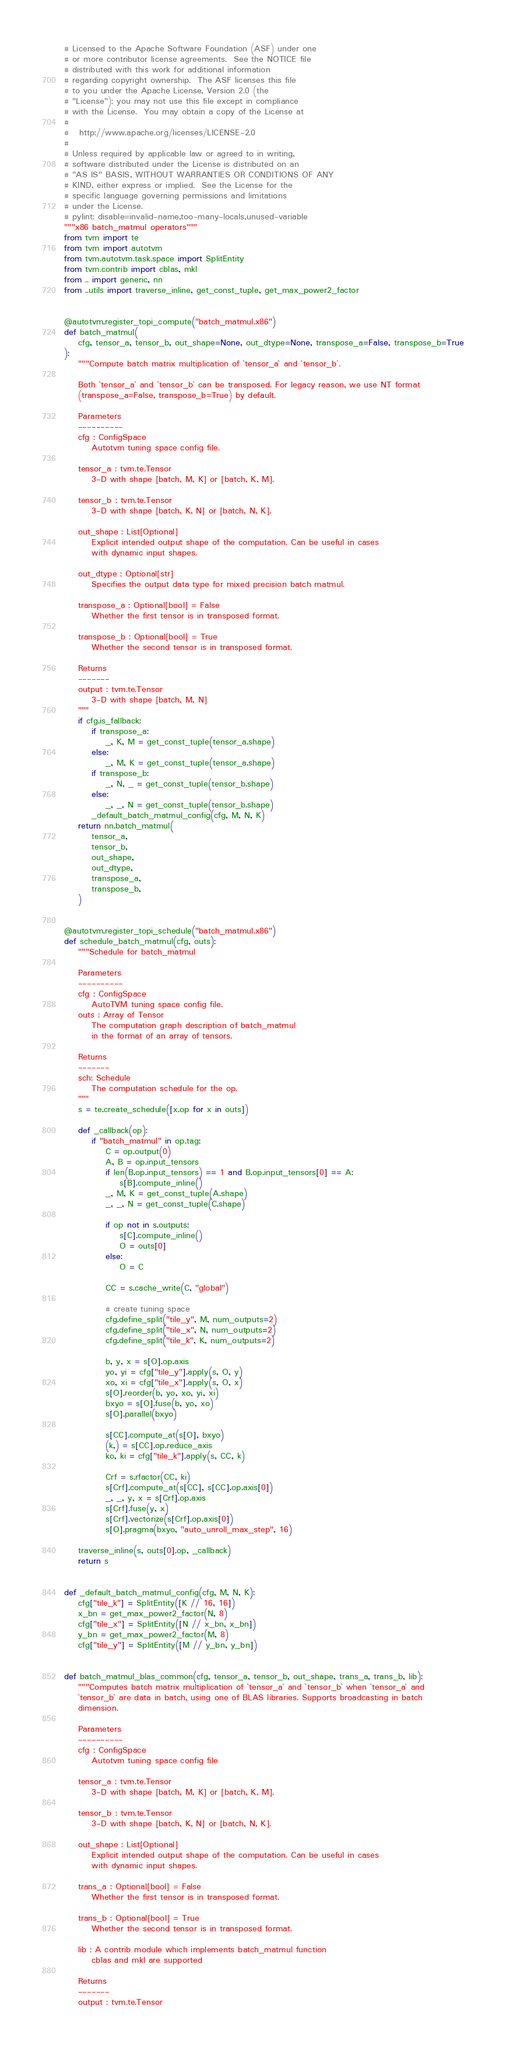Convert code to text. <code><loc_0><loc_0><loc_500><loc_500><_Python_># Licensed to the Apache Software Foundation (ASF) under one
# or more contributor license agreements.  See the NOTICE file
# distributed with this work for additional information
# regarding copyright ownership.  The ASF licenses this file
# to you under the Apache License, Version 2.0 (the
# "License"); you may not use this file except in compliance
# with the License.  You may obtain a copy of the License at
#
#   http://www.apache.org/licenses/LICENSE-2.0
#
# Unless required by applicable law or agreed to in writing,
# software distributed under the License is distributed on an
# "AS IS" BASIS, WITHOUT WARRANTIES OR CONDITIONS OF ANY
# KIND, either express or implied.  See the License for the
# specific language governing permissions and limitations
# under the License.
# pylint: disable=invalid-name,too-many-locals,unused-variable
"""x86 batch_matmul operators"""
from tvm import te
from tvm import autotvm
from tvm.autotvm.task.space import SplitEntity
from tvm.contrib import cblas, mkl
from .. import generic, nn
from ..utils import traverse_inline, get_const_tuple, get_max_power2_factor


@autotvm.register_topi_compute("batch_matmul.x86")
def batch_matmul(
    cfg, tensor_a, tensor_b, out_shape=None, out_dtype=None, transpose_a=False, transpose_b=True
):
    """Compute batch matrix multiplication of `tensor_a` and `tensor_b`.

    Both `tensor_a` and `tensor_b` can be transposed. For legacy reason, we use NT format
    (transpose_a=False, transpose_b=True) by default.

    Parameters
    ----------
    cfg : ConfigSpace
        Autotvm tuning space config file.

    tensor_a : tvm.te.Tensor
        3-D with shape [batch, M, K] or [batch, K, M].

    tensor_b : tvm.te.Tensor
        3-D with shape [batch, K, N] or [batch, N, K].

    out_shape : List[Optional]
        Explicit intended output shape of the computation. Can be useful in cases
        with dynamic input shapes.

    out_dtype : Optional[str]
        Specifies the output data type for mixed precision batch matmul.

    transpose_a : Optional[bool] = False
        Whether the first tensor is in transposed format.

    transpose_b : Optional[bool] = True
        Whether the second tensor is in transposed format.

    Returns
    -------
    output : tvm.te.Tensor
        3-D with shape [batch, M, N]
    """
    if cfg.is_fallback:
        if transpose_a:
            _, K, M = get_const_tuple(tensor_a.shape)
        else:
            _, M, K = get_const_tuple(tensor_a.shape)
        if transpose_b:
            _, N, _ = get_const_tuple(tensor_b.shape)
        else:
            _, _, N = get_const_tuple(tensor_b.shape)
        _default_batch_matmul_config(cfg, M, N, K)
    return nn.batch_matmul(
        tensor_a,
        tensor_b,
        out_shape,
        out_dtype,
        transpose_a,
        transpose_b,
    )


@autotvm.register_topi_schedule("batch_matmul.x86")
def schedule_batch_matmul(cfg, outs):
    """Schedule for batch_matmul

    Parameters
    ----------
    cfg : ConfigSpace
        AutoTVM tuning space config file.
    outs : Array of Tensor
        The computation graph description of batch_matmul
        in the format of an array of tensors.

    Returns
    -------
    sch: Schedule
        The computation schedule for the op.
    """
    s = te.create_schedule([x.op for x in outs])

    def _callback(op):
        if "batch_matmul" in op.tag:
            C = op.output(0)
            A, B = op.input_tensors
            if len(B.op.input_tensors) == 1 and B.op.input_tensors[0] == A:
                s[B].compute_inline()
            _, M, K = get_const_tuple(A.shape)
            _, _, N = get_const_tuple(C.shape)

            if op not in s.outputs:
                s[C].compute_inline()
                O = outs[0]
            else:
                O = C

            CC = s.cache_write(C, "global")

            # create tuning space
            cfg.define_split("tile_y", M, num_outputs=2)
            cfg.define_split("tile_x", N, num_outputs=2)
            cfg.define_split("tile_k", K, num_outputs=2)

            b, y, x = s[O].op.axis
            yo, yi = cfg["tile_y"].apply(s, O, y)
            xo, xi = cfg["tile_x"].apply(s, O, x)
            s[O].reorder(b, yo, xo, yi, xi)
            bxyo = s[O].fuse(b, yo, xo)
            s[O].parallel(bxyo)

            s[CC].compute_at(s[O], bxyo)
            (k,) = s[CC].op.reduce_axis
            ko, ki = cfg["tile_k"].apply(s, CC, k)

            Crf = s.rfactor(CC, ki)
            s[Crf].compute_at(s[CC], s[CC].op.axis[0])
            _, _, y, x = s[Crf].op.axis
            s[Crf].fuse(y, x)
            s[Crf].vectorize(s[Crf].op.axis[0])
            s[O].pragma(bxyo, "auto_unroll_max_step", 16)

    traverse_inline(s, outs[0].op, _callback)
    return s


def _default_batch_matmul_config(cfg, M, N, K):
    cfg["tile_k"] = SplitEntity([K // 16, 16])
    x_bn = get_max_power2_factor(N, 8)
    cfg["tile_x"] = SplitEntity([N // x_bn, x_bn])
    y_bn = get_max_power2_factor(M, 8)
    cfg["tile_y"] = SplitEntity([M // y_bn, y_bn])


def batch_matmul_blas_common(cfg, tensor_a, tensor_b, out_shape, trans_a, trans_b, lib):
    """Computes batch matrix multiplication of `tensor_a` and `tensor_b` when `tensor_a` and
    `tensor_b` are data in batch, using one of BLAS libraries. Supports broadcasting in batch
    dimension.

    Parameters
    ----------
    cfg : ConfigSpace
        Autotvm tuning space config file

    tensor_a : tvm.te.Tensor
        3-D with shape [batch, M, K] or [batch, K, M].

    tensor_b : tvm.te.Tensor
        3-D with shape [batch, K, N] or [batch, N, K].

    out_shape : List[Optional]
        Explicit intended output shape of the computation. Can be useful in cases
        with dynamic input shapes.

    trans_a : Optional[bool] = False
        Whether the first tensor is in transposed format.

    trans_b : Optional[bool] = True
        Whether the second tensor is in transposed format.

    lib : A contrib module which implements batch_matmul function
        cblas and mkl are supported

    Returns
    -------
    output : tvm.te.Tensor</code> 